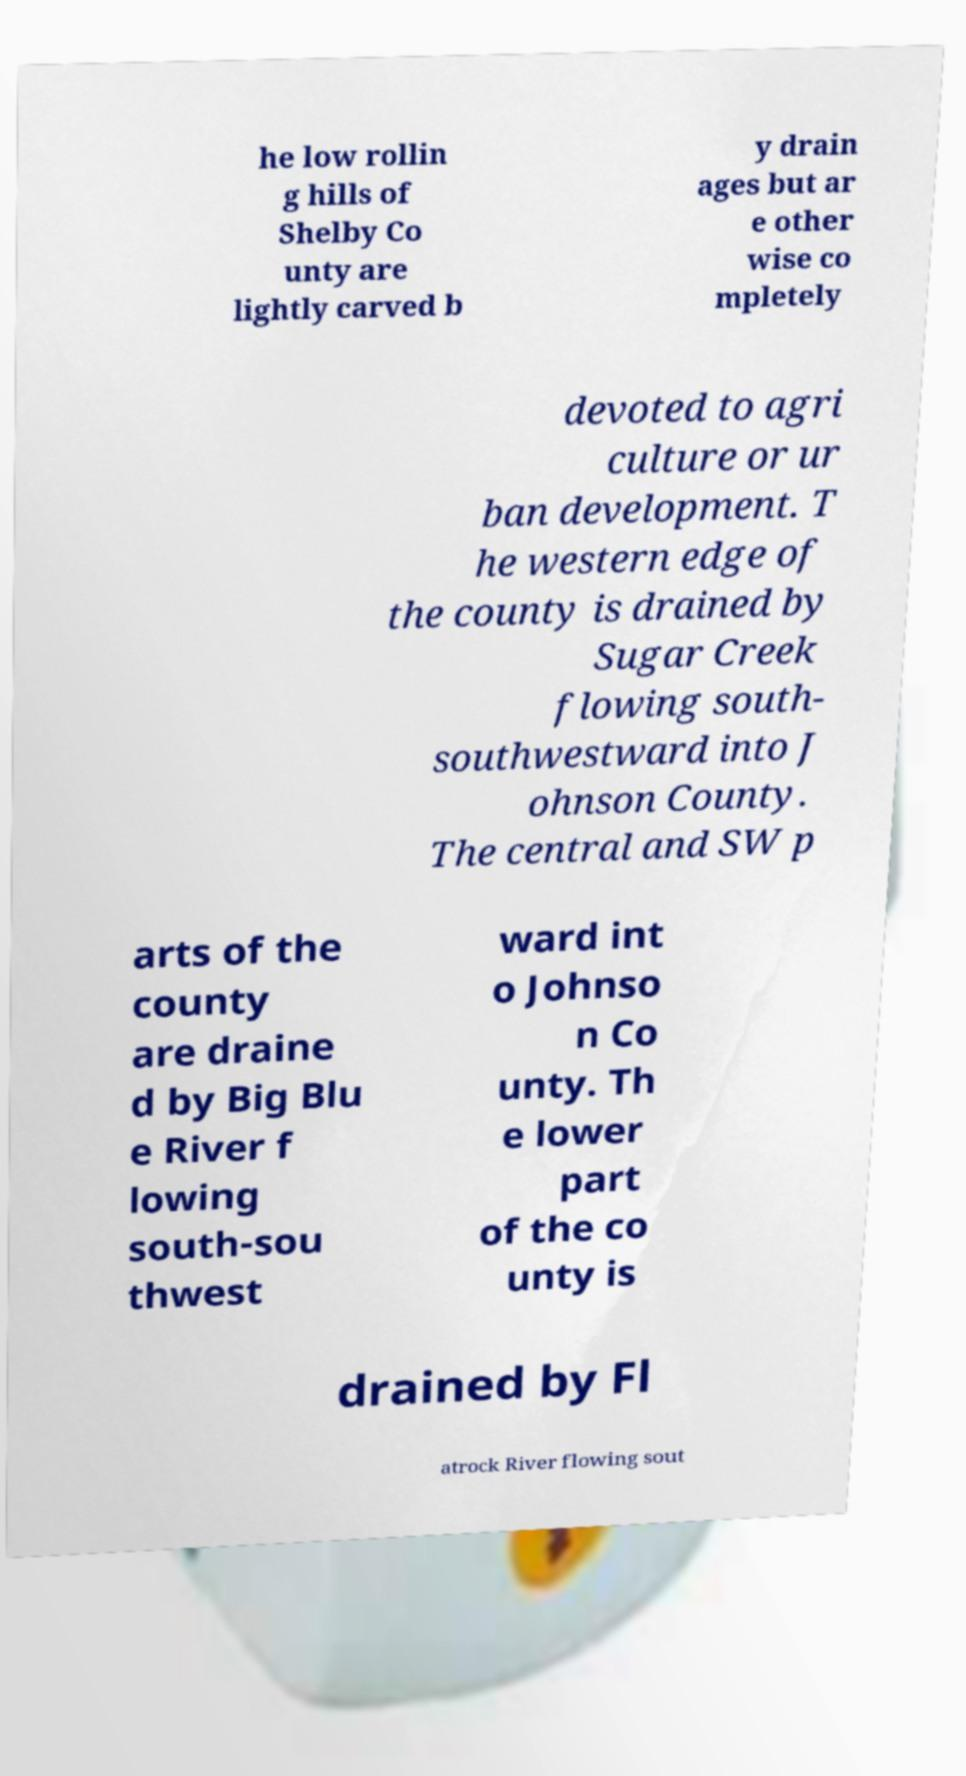I need the written content from this picture converted into text. Can you do that? he low rollin g hills of Shelby Co unty are lightly carved b y drain ages but ar e other wise co mpletely devoted to agri culture or ur ban development. T he western edge of the county is drained by Sugar Creek flowing south- southwestward into J ohnson County. The central and SW p arts of the county are draine d by Big Blu e River f lowing south-sou thwest ward int o Johnso n Co unty. Th e lower part of the co unty is drained by Fl atrock River flowing sout 